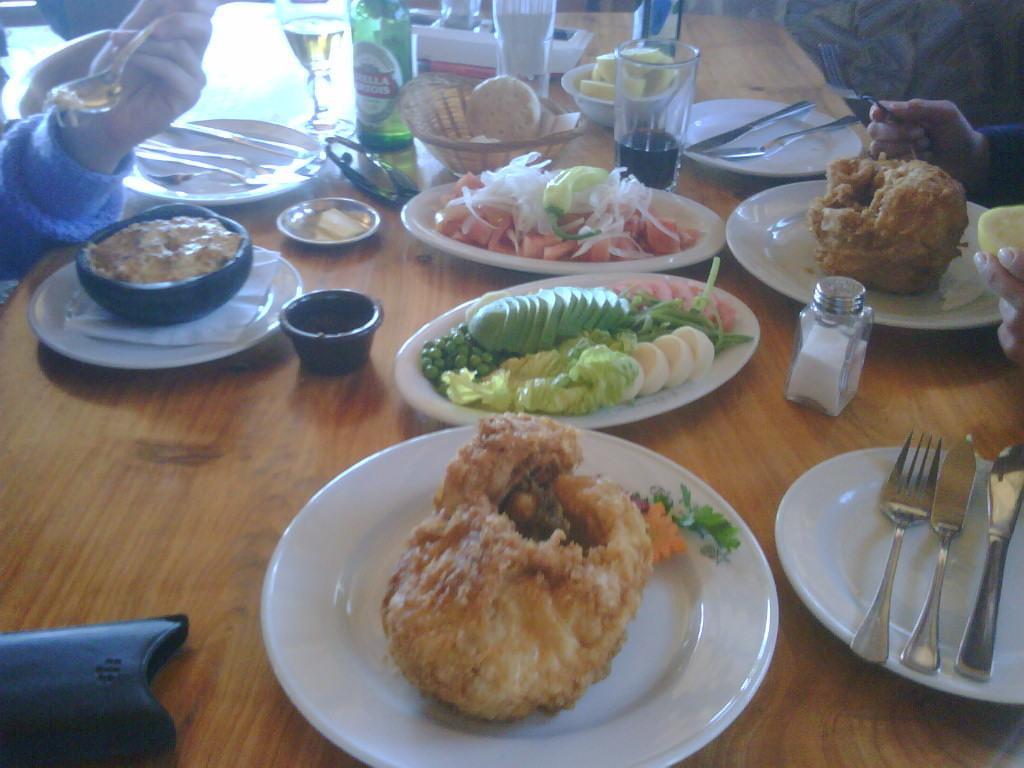How would you summarize this image in a sentence or two? In this image there are food items in a plate. There are glasses, wine bottles, forks and a few other objects on the table. Beside the table there are people. 